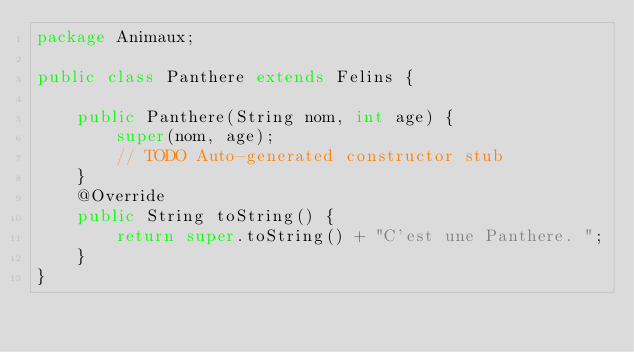<code> <loc_0><loc_0><loc_500><loc_500><_Java_>package Animaux;

public class Panthere extends Felins {

	public Panthere(String nom, int age) {
		super(nom, age);
		// TODO Auto-generated constructor stub
	}
	@Override
	public String toString() {
		return super.toString() + "C'est une Panthere. ";
	}
}
</code> 